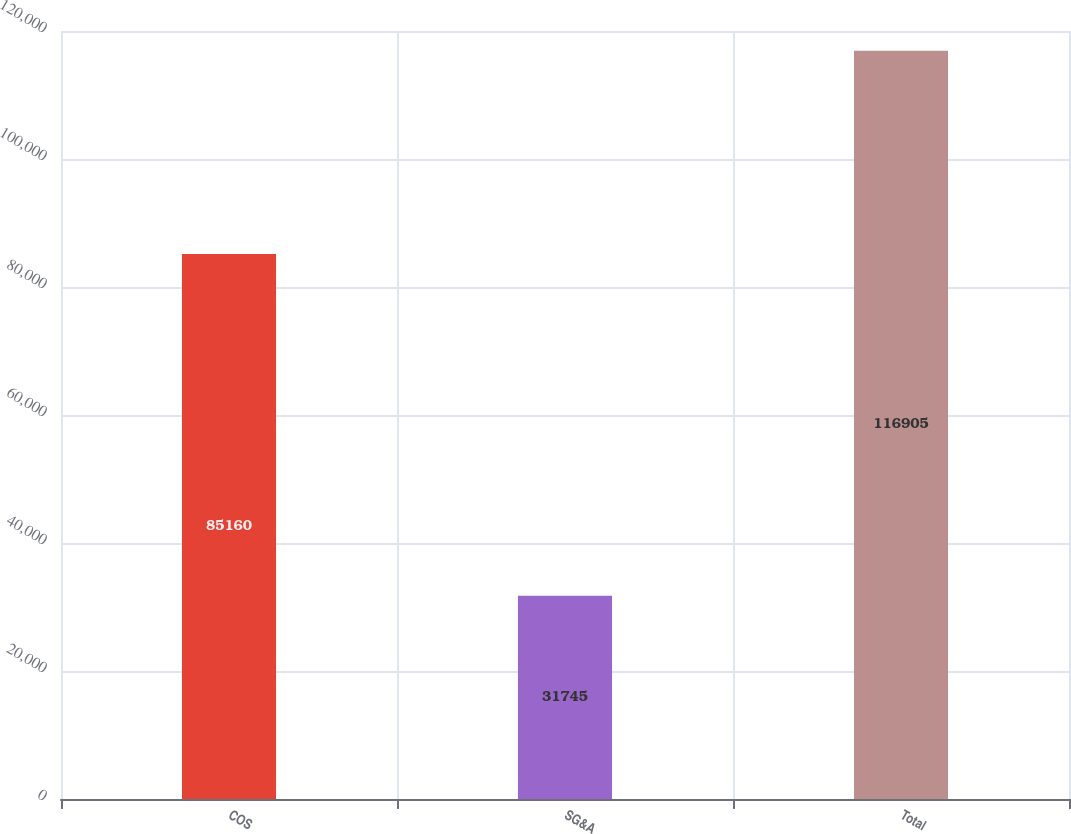Convert chart to OTSL. <chart><loc_0><loc_0><loc_500><loc_500><bar_chart><fcel>COS<fcel>SG&A<fcel>Total<nl><fcel>85160<fcel>31745<fcel>116905<nl></chart> 